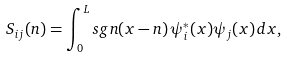<formula> <loc_0><loc_0><loc_500><loc_500>S _ { i j } ( n ) = \int _ { 0 } ^ { L } s g n ( x - n ) \, \psi _ { i } ^ { * } ( x ) \psi _ { j } ( x ) \, d x ,</formula> 